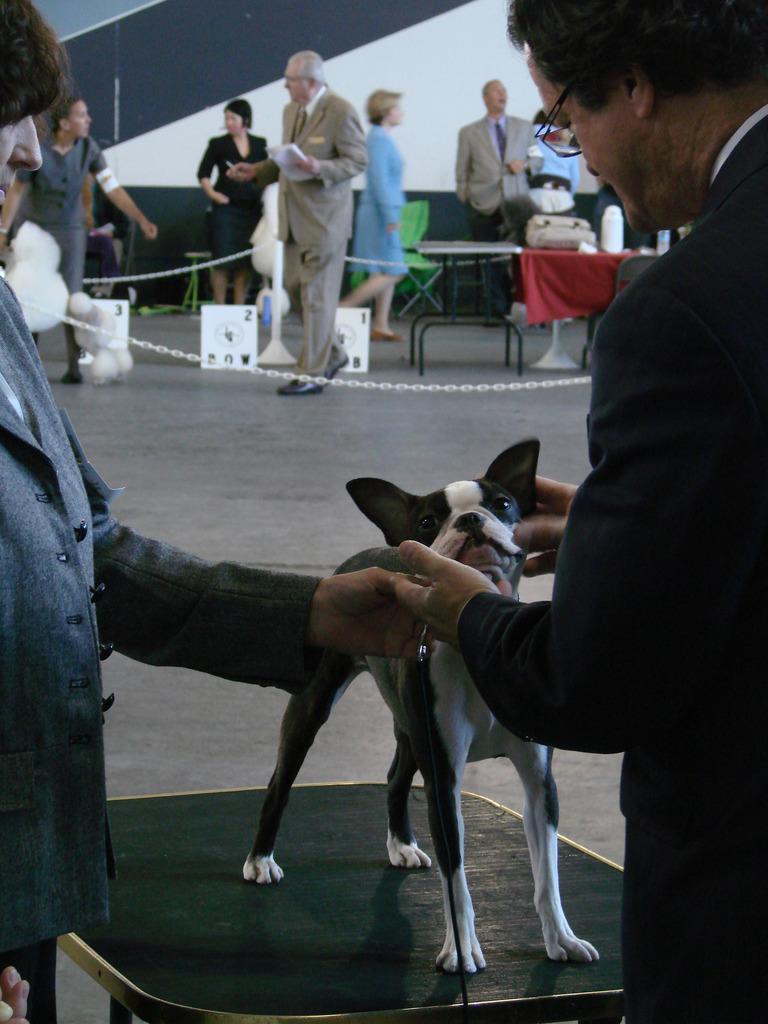What can be seen in the image? There are persons standing in the image, along with a table and a dog. Can you describe the table in the image? The table is a piece of furniture that is present in the image. What type of animal is in the image? There is a dog in the image. What type of lift is present in the image? There is no lift present in the image. What kind of machine can be seen operating in the image? There are no machines operating in the image. 